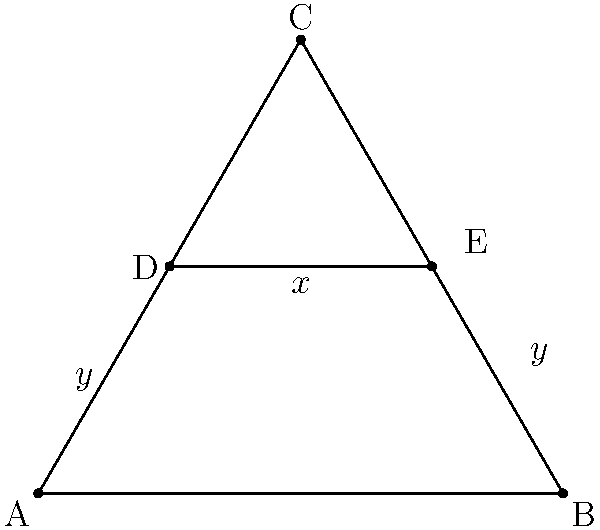In your investigation of geometric patterns in Islamic architecture, you come across a design featuring an equilateral triangle with a line segment parallel to its base. If the side length of the triangle is 4 units and the parallel line segment divides the two sides of the triangle in a 1:2 ratio, what is the length of this line segment? Let's approach this step-by-step:

1) First, we need to understand the properties of an equilateral triangle:
   - All sides are equal
   - All angles are 60°
   - The height (h) of an equilateral triangle with side length s is given by:
     $$h = \frac{\sqrt{3}}{2}s$$

2) In this case, the side length is 4 units, so the height is:
   $$h = \frac{\sqrt{3}}{2} * 4 = 2\sqrt{3}$$

3) The parallel line segment divides the sides in a 1:2 ratio. This means it's located at 1/3 of the height from the base:
   $$y = \frac{1}{3} * 2\sqrt{3} = \frac{2\sqrt{3}}{3}$$

4) Now, we can use the property of similar triangles. The ratio of the parallel line segment (x) to the base of the triangle (4) is the same as the ratio of its distance from the top (2y) to the height of the triangle (h):

   $$\frac{x}{4} = \frac{2y}{h} = \frac{2 * \frac{2\sqrt{3}}{3}}{2\sqrt{3}} = \frac{2}{3}$$

5) Solving for x:
   $$x = 4 * \frac{2}{3} = \frac{8}{3}$$

Therefore, the length of the parallel line segment is $\frac{8}{3}$ units.
Answer: $\frac{8}{3}$ units 